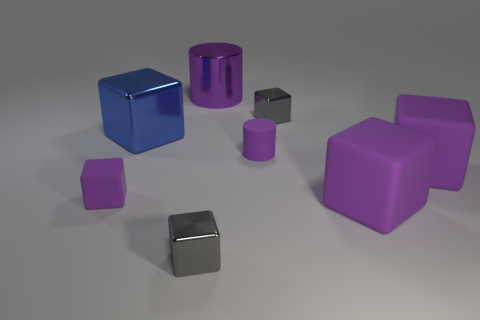Does the tiny purple matte object on the left side of the matte cylinder have the same shape as the big purple metal thing?
Provide a succinct answer. No. There is a tiny shiny object behind the large blue cube; what is its shape?
Your answer should be compact. Cube. The small purple object that is the same material as the small cylinder is what shape?
Provide a short and direct response. Cube. How many metal things are either blue cubes or small purple things?
Your answer should be compact. 1. There is a large cube that is behind the tiny rubber thing that is to the right of the small purple matte block; what number of small blocks are behind it?
Offer a very short reply. 1. Do the purple cylinder that is behind the small purple matte cylinder and the gray object behind the large blue cube have the same size?
Your response must be concise. No. There is another thing that is the same shape as the purple shiny thing; what is its material?
Ensure brevity in your answer.  Rubber. How many large objects are either purple matte cylinders or rubber objects?
Your answer should be compact. 2. What material is the big cylinder?
Your answer should be very brief. Metal. There is a block that is both to the right of the small matte cylinder and in front of the small purple block; what is it made of?
Keep it short and to the point. Rubber. 